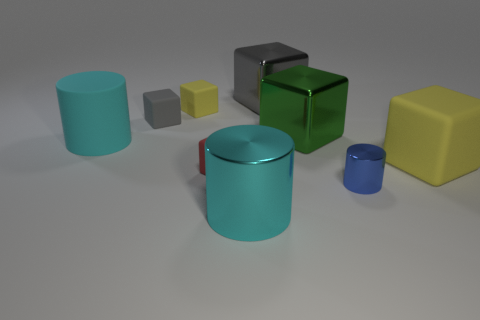Subtract all green blocks. How many blocks are left? 5 Subtract all shiny blocks. How many blocks are left? 4 Subtract 1 cubes. How many cubes are left? 5 Subtract all green blocks. Subtract all brown balls. How many blocks are left? 5 Subtract all cylinders. How many objects are left? 6 Subtract all gray rubber balls. Subtract all tiny yellow matte cubes. How many objects are left? 8 Add 1 cyan metal things. How many cyan metal things are left? 2 Add 5 tiny red cylinders. How many tiny red cylinders exist? 5 Subtract 0 yellow cylinders. How many objects are left? 9 